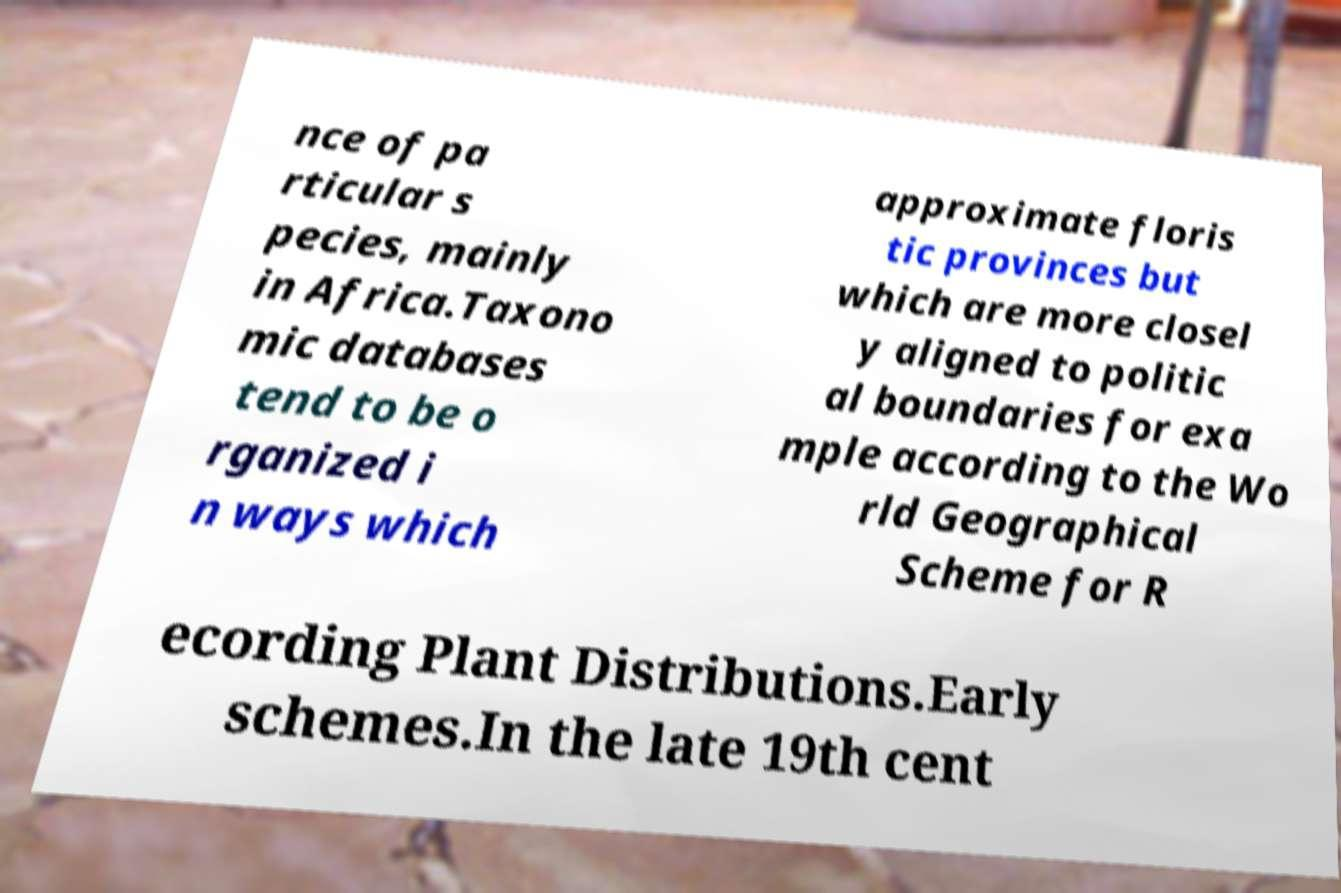Can you read and provide the text displayed in the image?This photo seems to have some interesting text. Can you extract and type it out for me? nce of pa rticular s pecies, mainly in Africa.Taxono mic databases tend to be o rganized i n ways which approximate floris tic provinces but which are more closel y aligned to politic al boundaries for exa mple according to the Wo rld Geographical Scheme for R ecording Plant Distributions.Early schemes.In the late 19th cent 